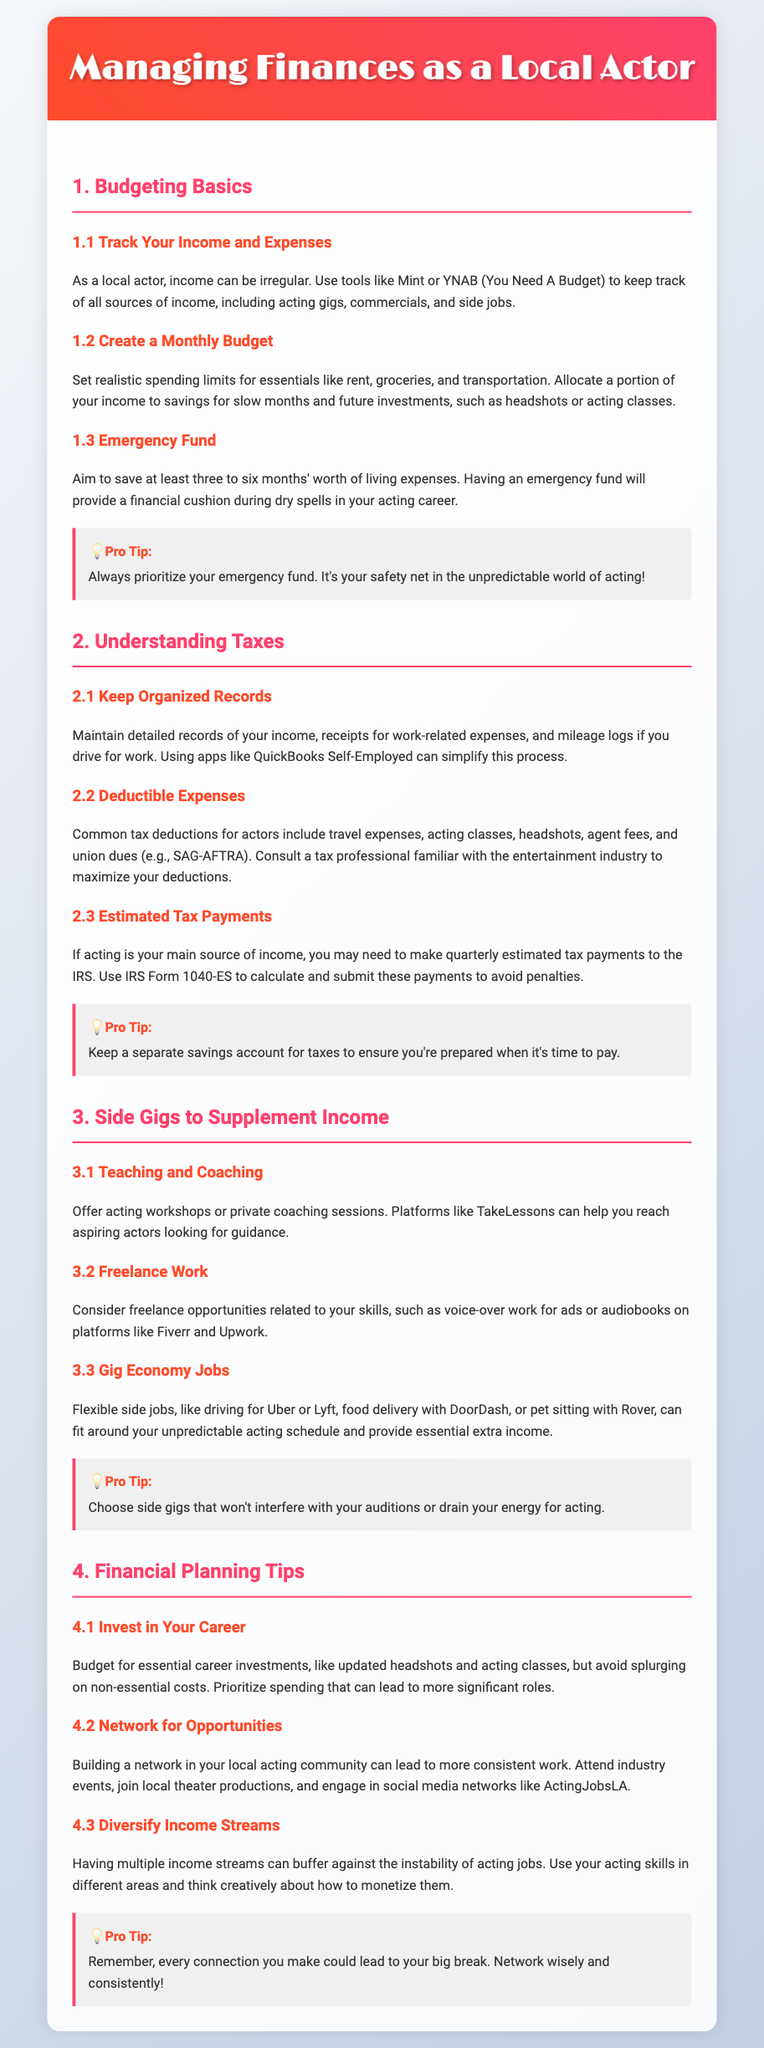What is the first budgeting basic mentioned? The first budgeting basic in the document is about tracking your income and expenses.
Answer: Track Your Income and Expenses How many months' worth of living expenses should you save for an emergency fund? The document advises saving at least three to six months' worth of living expenses.
Answer: Three to six months Which tax form is mentioned for estimated tax payments? The document refers to IRS Form 1040-ES for estimated tax payments.
Answer: Form 1040-ES What is one side gig suggested for local actors? The document suggests offering acting workshops or private coaching sessions as a side gig.
Answer: Teaching and Coaching What should you budget for to invest in your career? The document advises budgeting for essential career investments like updated headshots and acting classes.
Answer: Updated headshots and acting classes What is a pro tip regarding the emergency fund? The document states to always prioritize your emergency fund as it's your safety net in acting.
Answer: Prioritize your emergency fund How can you diversify income streams according to the document? The document suggests using your acting skills in different areas and thinking creatively about how to monetize them.
Answer: Use acting skills in different areas What is one method of keeping organized records for taxes? The document recommends using apps like QuickBooks Self-Employed to keep organized records.
Answer: QuickBooks Self-Employed 